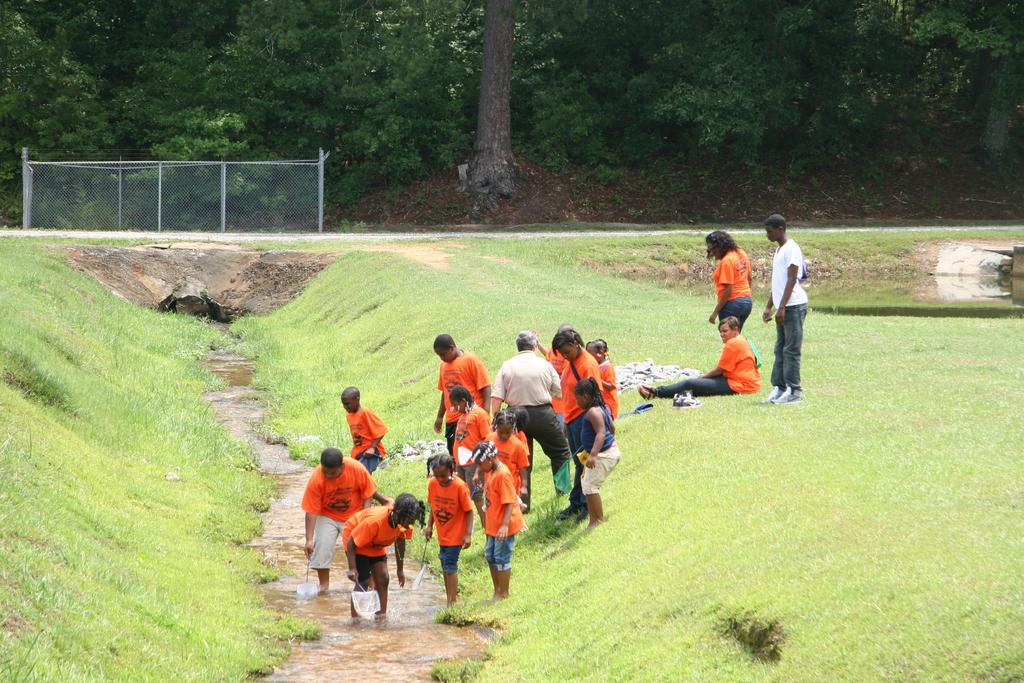How many people are in the image? There is a group of people in the image, but the exact number is not specified. What are the people in the image doing? Some people are standing, while one person is seated on the grass. What can be seen in the background of the image? There are trees, metal rods, and a net visible in the background of the image. What is the primary feature of the landscape in the image? Water is visible in the image, suggesting a waterfront or body of water. What type of vegetable is being stretched by the person seated on the grass in the image? There is no vegetable present in the image, nor is anyone stretching anything. 